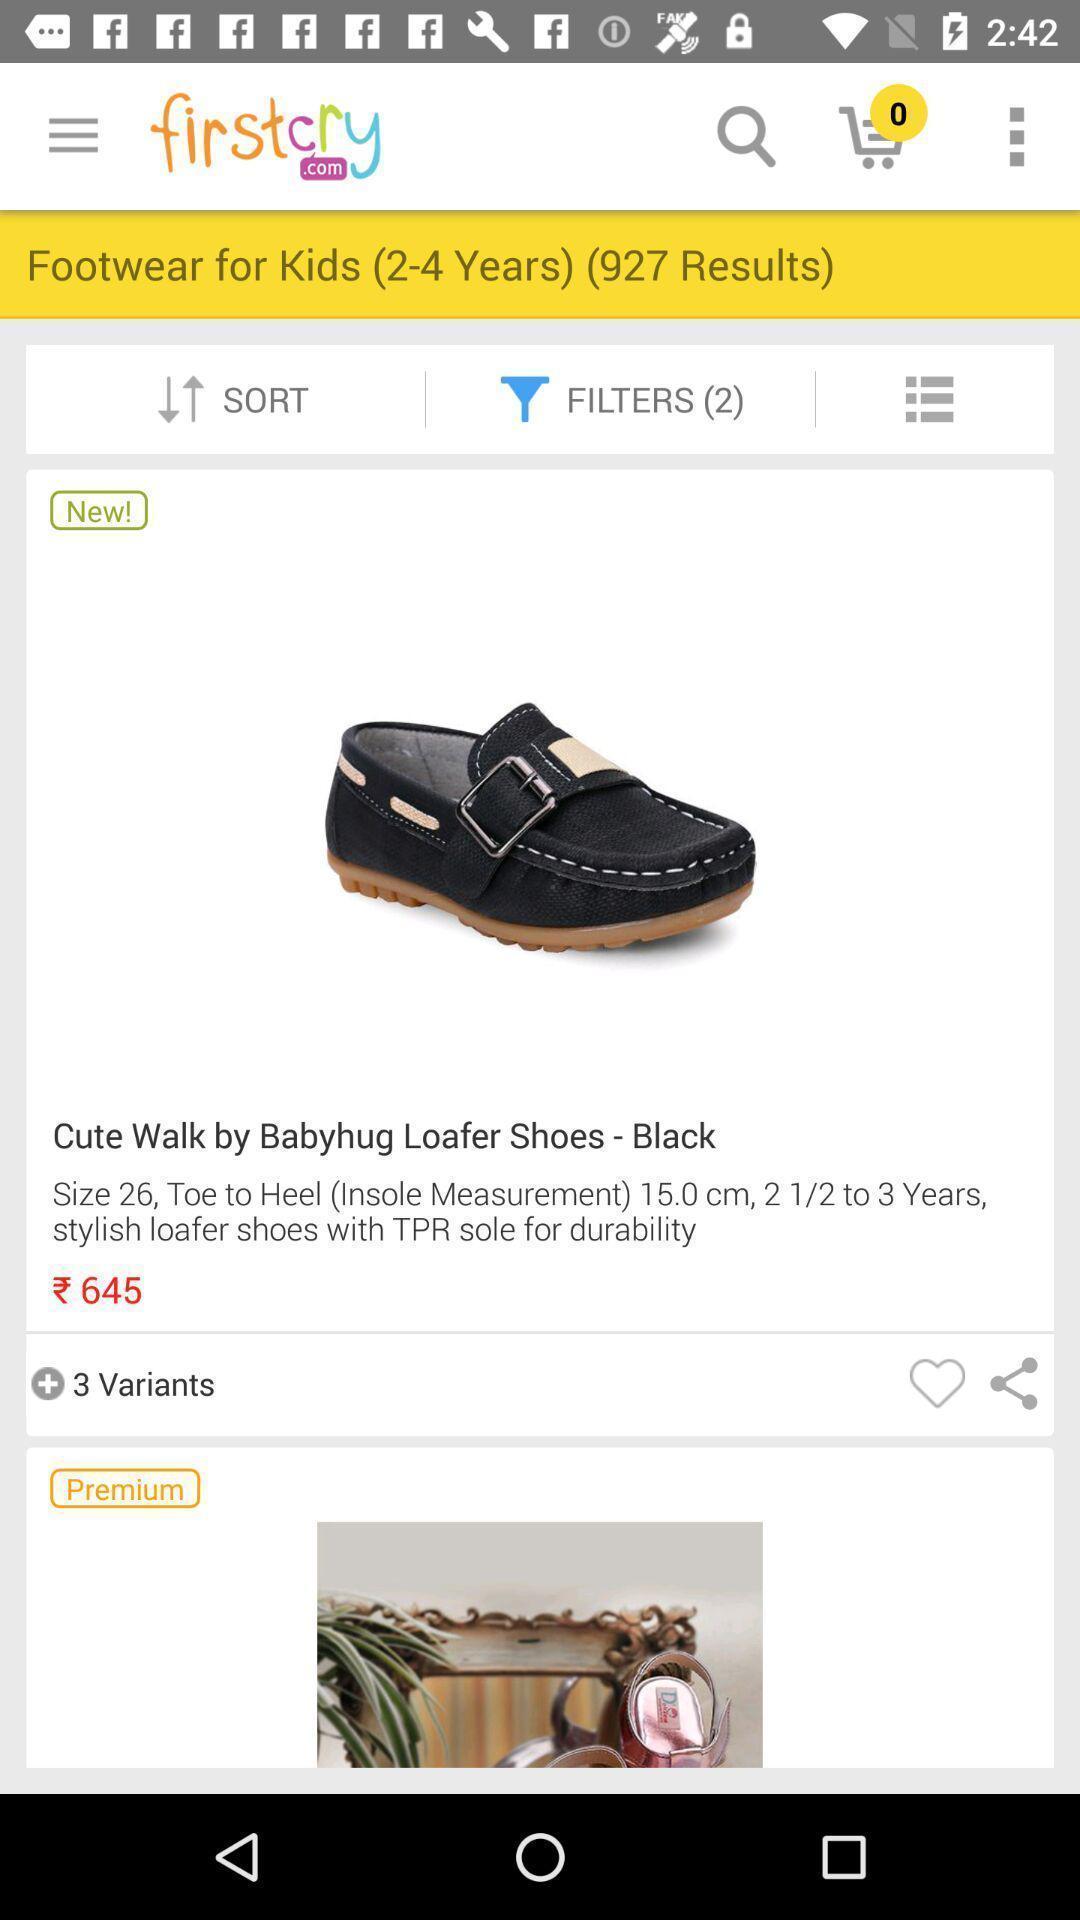Provide a description of this screenshot. Page for the service application. 